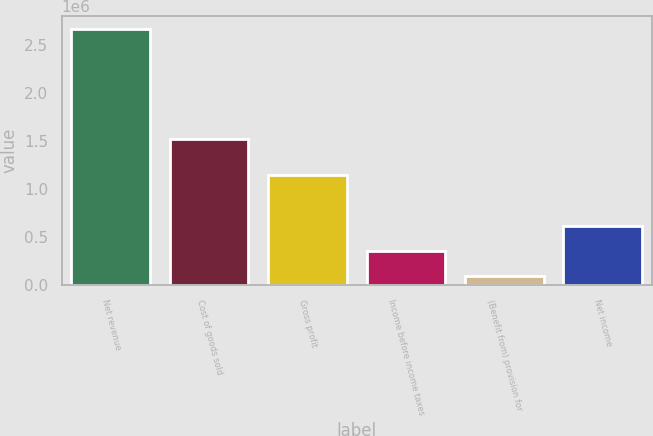Convert chart. <chart><loc_0><loc_0><loc_500><loc_500><bar_chart><fcel>Net revenue<fcel>Cost of goods sold<fcel>Gross profit<fcel>Income before income taxes<fcel>(Benefit from) provision for<fcel>Net income<nl><fcel>2.66839e+06<fcel>1.52364e+06<fcel>1.14475e+06<fcel>357786<fcel>101052<fcel>614520<nl></chart> 